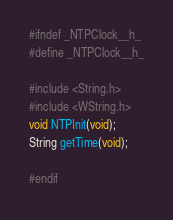Convert code to text. <code><loc_0><loc_0><loc_500><loc_500><_C_>#ifndef _NTPClock__h_
#define _NTPClock__h_

#include <String.h>
#include <WString.h> 
void NTPInit(void);
String getTime(void);

#endif
</code> 